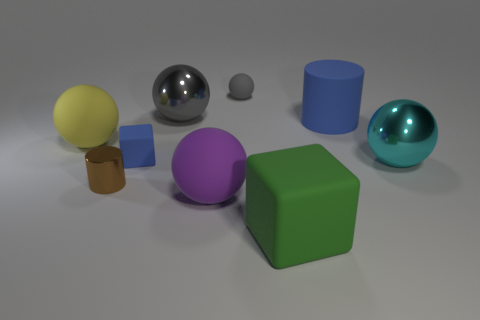There is a rubber object that is the same color as the tiny matte block; what is its shape?
Give a very brief answer. Cylinder. Do the yellow object and the small thing that is behind the large blue matte object have the same shape?
Your response must be concise. Yes. What number of tiny objects are either yellow rubber things or brown shiny things?
Keep it short and to the point. 1. Are there any gray spheres of the same size as the yellow thing?
Offer a terse response. Yes. The matte object that is in front of the purple sphere that is in front of the blue rubber object left of the small matte sphere is what color?
Ensure brevity in your answer.  Green. Does the small gray ball have the same material as the cylinder that is on the left side of the tiny ball?
Make the answer very short. No. There is a gray rubber thing that is the same shape as the yellow object; what is its size?
Make the answer very short. Small. Is the number of blue matte cylinders to the left of the cyan shiny thing the same as the number of big spheres that are left of the small blue rubber thing?
Your answer should be compact. Yes. What number of other things are there of the same material as the big cylinder
Your answer should be very brief. 5. Are there an equal number of tiny brown shiny cylinders to the right of the small gray ball and gray metallic cylinders?
Provide a succinct answer. Yes. 